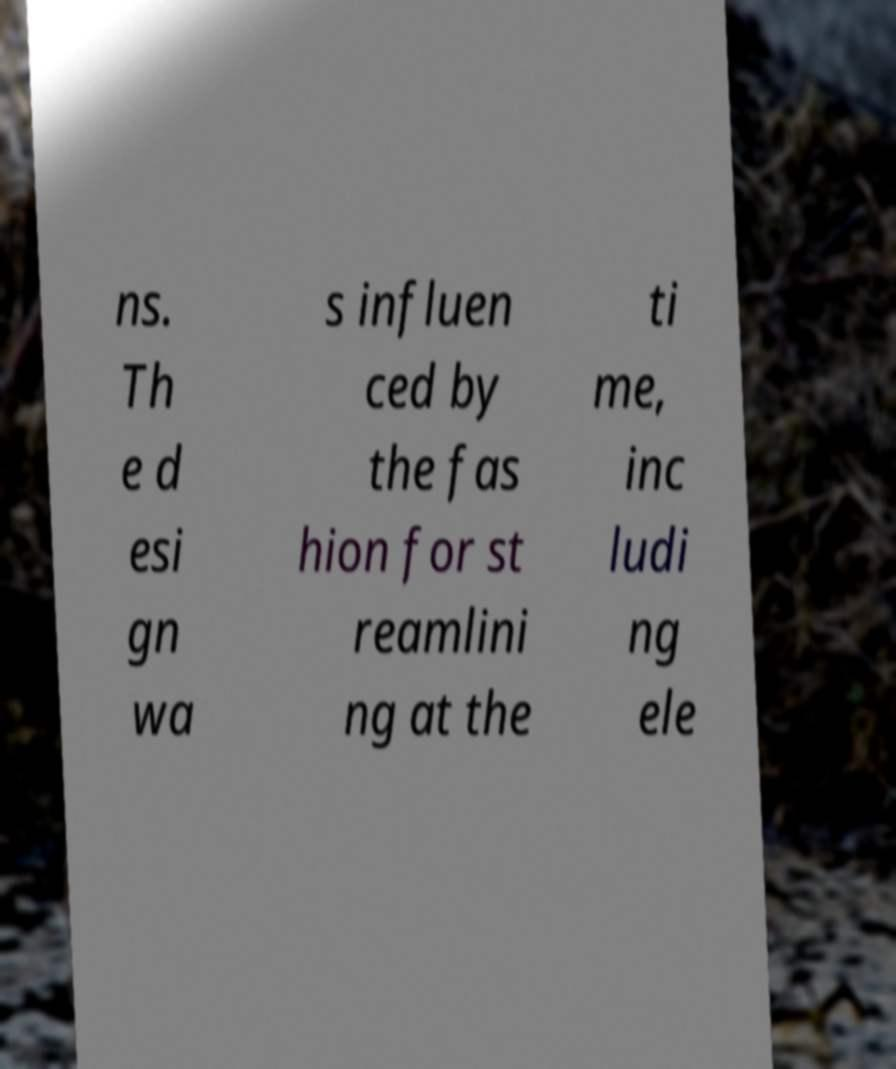Can you accurately transcribe the text from the provided image for me? ns. Th e d esi gn wa s influen ced by the fas hion for st reamlini ng at the ti me, inc ludi ng ele 